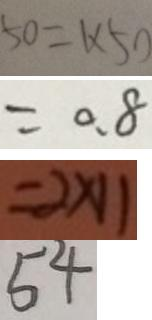Convert formula to latex. <formula><loc_0><loc_0><loc_500><loc_500>5 0 = 1 \times 5 0 
 = 0 . 8 
 = 2 \times 1 1 
 5 4</formula> 